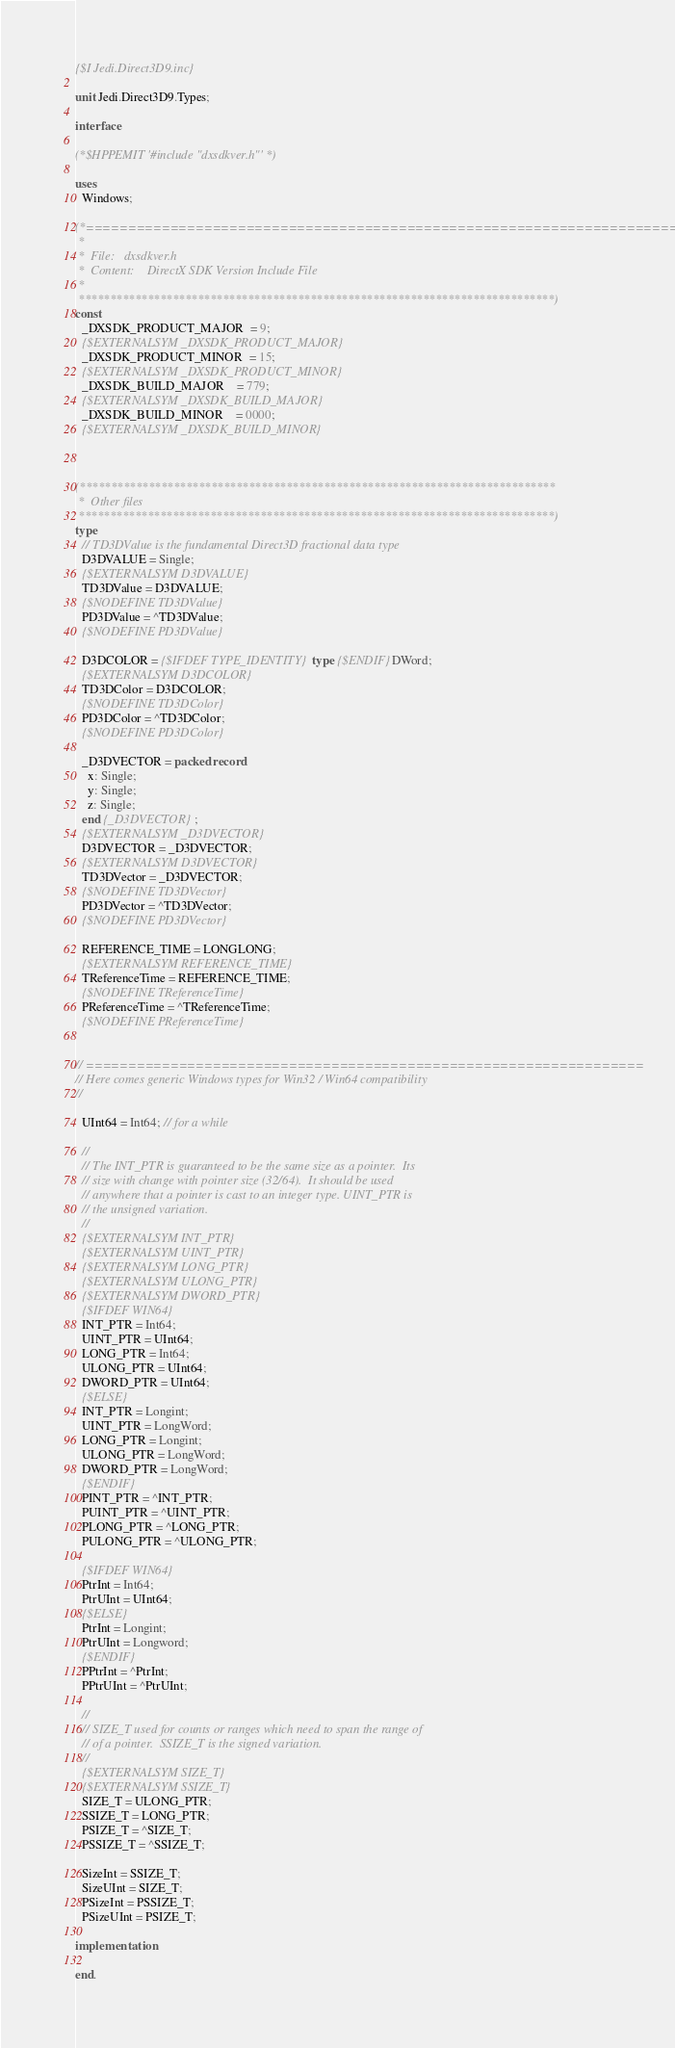Convert code to text. <code><loc_0><loc_0><loc_500><loc_500><_Pascal_>
{$I Jedi.Direct3D9.inc}

unit Jedi.Direct3D9.Types;

interface

(*$HPPEMIT '#include "dxsdkver.h"' *)

uses
  Windows;

(*==========================================================================;
 *
 *  File:   dxsdkver.h
 *  Content:    DirectX SDK Version Include File
 *
 ****************************************************************************)
const
  _DXSDK_PRODUCT_MAJOR  = 9;
  {$EXTERNALSYM _DXSDK_PRODUCT_MAJOR}
  _DXSDK_PRODUCT_MINOR  = 15;
  {$EXTERNALSYM _DXSDK_PRODUCT_MINOR}
  _DXSDK_BUILD_MAJOR    = 779;
  {$EXTERNALSYM _DXSDK_BUILD_MAJOR}
  _DXSDK_BUILD_MINOR    = 0000;
  {$EXTERNALSYM _DXSDK_BUILD_MINOR}



(****************************************************************************
 *  Other files
 ****************************************************************************)
type
  // TD3DValue is the fundamental Direct3D fractional data type
  D3DVALUE = Single;
  {$EXTERNALSYM D3DVALUE}
  TD3DValue = D3DVALUE;
  {$NODEFINE TD3DValue}
  PD3DValue = ^TD3DValue;
  {$NODEFINE PD3DValue}

  D3DCOLOR = {$IFDEF TYPE_IDENTITY}type {$ENDIF}DWord;
  {$EXTERNALSYM D3DCOLOR}
  TD3DColor = D3DCOLOR;
  {$NODEFINE TD3DColor}
  PD3DColor = ^TD3DColor;
  {$NODEFINE PD3DColor}

  _D3DVECTOR = packed record
    x: Single;
    y: Single;
    z: Single;
  end {_D3DVECTOR};
  {$EXTERNALSYM _D3DVECTOR}
  D3DVECTOR = _D3DVECTOR;
  {$EXTERNALSYM D3DVECTOR}
  TD3DVector = _D3DVECTOR;
  {$NODEFINE TD3DVector}
  PD3DVector = ^TD3DVector;
  {$NODEFINE PD3DVector}

  REFERENCE_TIME = LONGLONG;
  {$EXTERNALSYM REFERENCE_TIME}
  TReferenceTime = REFERENCE_TIME;
  {$NODEFINE TReferenceTime}
  PReferenceTime = ^TReferenceTime;
  {$NODEFINE PReferenceTime}


// ==================================================================
// Here comes generic Windows types for Win32 / Win64 compatibility
//

  UInt64 = Int64; // for a while

  //
  // The INT_PTR is guaranteed to be the same size as a pointer.  Its
  // size with change with pointer size (32/64).  It should be used
  // anywhere that a pointer is cast to an integer type. UINT_PTR is
  // the unsigned variation.
  //
  {$EXTERNALSYM INT_PTR}
  {$EXTERNALSYM UINT_PTR}
  {$EXTERNALSYM LONG_PTR}
  {$EXTERNALSYM ULONG_PTR}
  {$EXTERNALSYM DWORD_PTR}
  {$IFDEF WIN64}
  INT_PTR = Int64;
  UINT_PTR = UInt64;
  LONG_PTR = Int64;
  ULONG_PTR = UInt64;
  DWORD_PTR = UInt64;
  {$ELSE}
  INT_PTR = Longint;
  UINT_PTR = LongWord;
  LONG_PTR = Longint;
  ULONG_PTR = LongWord;
  DWORD_PTR = LongWord;
  {$ENDIF}
  PINT_PTR = ^INT_PTR;
  PUINT_PTR = ^UINT_PTR;
  PLONG_PTR = ^LONG_PTR;
  PULONG_PTR = ^ULONG_PTR;

  {$IFDEF WIN64}
  PtrInt = Int64;
  PtrUInt = UInt64;
  {$ELSE}
  PtrInt = Longint;
  PtrUInt = Longword;
  {$ENDIF}
  PPtrInt = ^PtrInt;
  PPtrUInt = ^PtrUInt;

  //
  // SIZE_T used for counts or ranges which need to span the range of
  // of a pointer.  SSIZE_T is the signed variation.
  //
  {$EXTERNALSYM SIZE_T}
  {$EXTERNALSYM SSIZE_T}
  SIZE_T = ULONG_PTR;
  SSIZE_T = LONG_PTR;
  PSIZE_T = ^SIZE_T;
  PSSIZE_T = ^SSIZE_T;

  SizeInt = SSIZE_T;
  SizeUInt = SIZE_T;
  PSizeInt = PSSIZE_T;
  PSizeUInt = PSIZE_T;

implementation

end.

</code> 